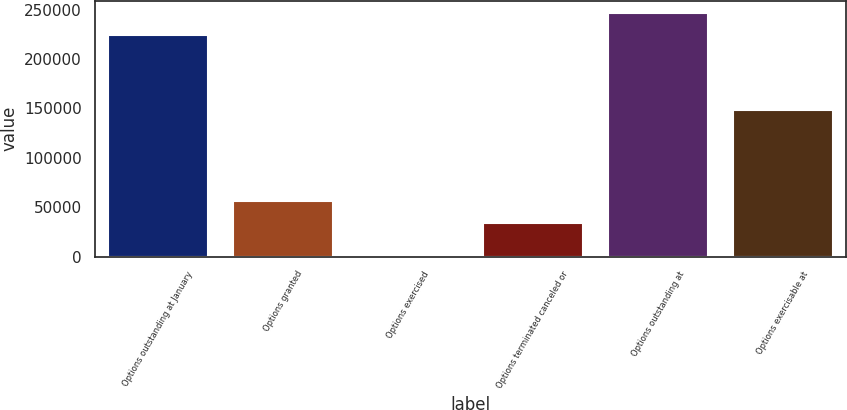Convert chart. <chart><loc_0><loc_0><loc_500><loc_500><bar_chart><fcel>Options outstanding at January<fcel>Options granted<fcel>Options exercised<fcel>Options terminated canceled or<fcel>Options outstanding at<fcel>Options exercisable at<nl><fcel>224255<fcel>56576.5<fcel>1920<fcel>33954<fcel>246878<fcel>148072<nl></chart> 